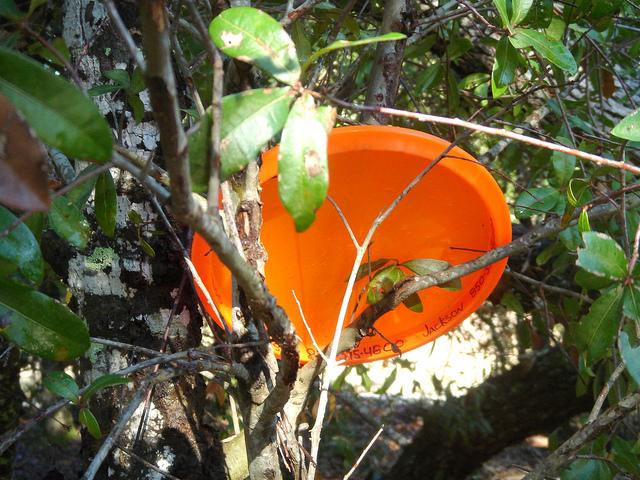How do you get that Frisbee out of the tree?
Give a very brief answer. Grab it. Is the photographer impressed with the throw that landed the Frisbee in the tree?
Short answer required. Yes. What color are the leaf's?
Short answer required. Green. 